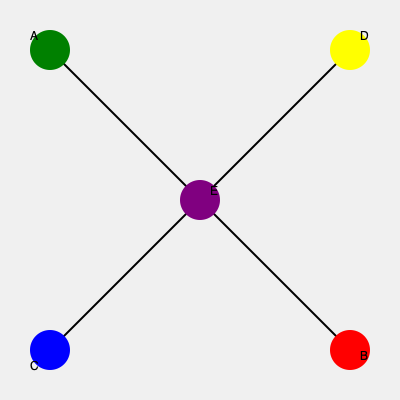Given a map with five charging stations (A, B, C, D, and E) represented by colored circles, what is the most efficient route to visit all stations starting from A and ending at B, assuming equal distances between directly connected stations? To find the most efficient route, we need to minimize the total distance traveled while visiting all stations. Let's analyze the possible routes:

1. The map shows that stations are arranged in a square pattern with station E in the center.
2. Direct connections exist between:
   - A and D
   - A and C
   - B and C
   - B and D
   - E and all other stations

3. Possible routes:
   a) A → E → C → D → B
   b) A → E → D → C → B
   c) A → C → E → D → B
   d) A → D → E → C → B

4. Routes (a) and (b) require 4 segments of travel.
5. Routes (c) and (d) also require 4 segments of travel.

6. Since all routes require the same number of segments and distances are equal between directly connected stations, they are all equally efficient.

7. However, considering the starting point A and ending point B, route (d) A → D → E → C → B is slightly more straightforward as it moves in a generally clockwise direction without backtracking.

Therefore, while all routes are technically equally efficient, the route A → D → E → C → B might be considered the most practical and easy to follow.
Answer: A → D → E → C → B 